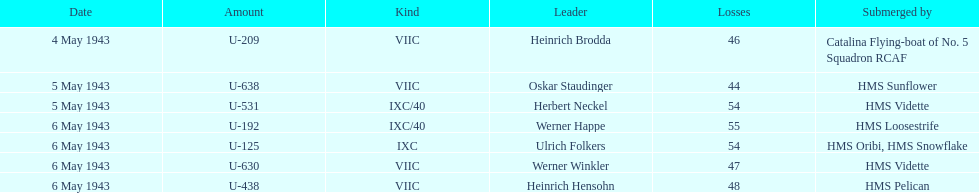Which sunken u-boat had the most casualties U-192. Give me the full table as a dictionary. {'header': ['Date', 'Amount', 'Kind', 'Leader', 'Losses', 'Submerged by'], 'rows': [['4 May 1943', 'U-209', 'VIIC', 'Heinrich Brodda', '46', 'Catalina Flying-boat of No. 5 Squadron RCAF'], ['5 May 1943', 'U-638', 'VIIC', 'Oskar Staudinger', '44', 'HMS Sunflower'], ['5 May 1943', 'U-531', 'IXC/40', 'Herbert Neckel', '54', 'HMS Vidette'], ['6 May 1943', 'U-192', 'IXC/40', 'Werner Happe', '55', 'HMS Loosestrife'], ['6 May 1943', 'U-125', 'IXC', 'Ulrich Folkers', '54', 'HMS Oribi, HMS Snowflake'], ['6 May 1943', 'U-630', 'VIIC', 'Werner Winkler', '47', 'HMS Vidette'], ['6 May 1943', 'U-438', 'VIIC', 'Heinrich Hensohn', '48', 'HMS Pelican']]} 